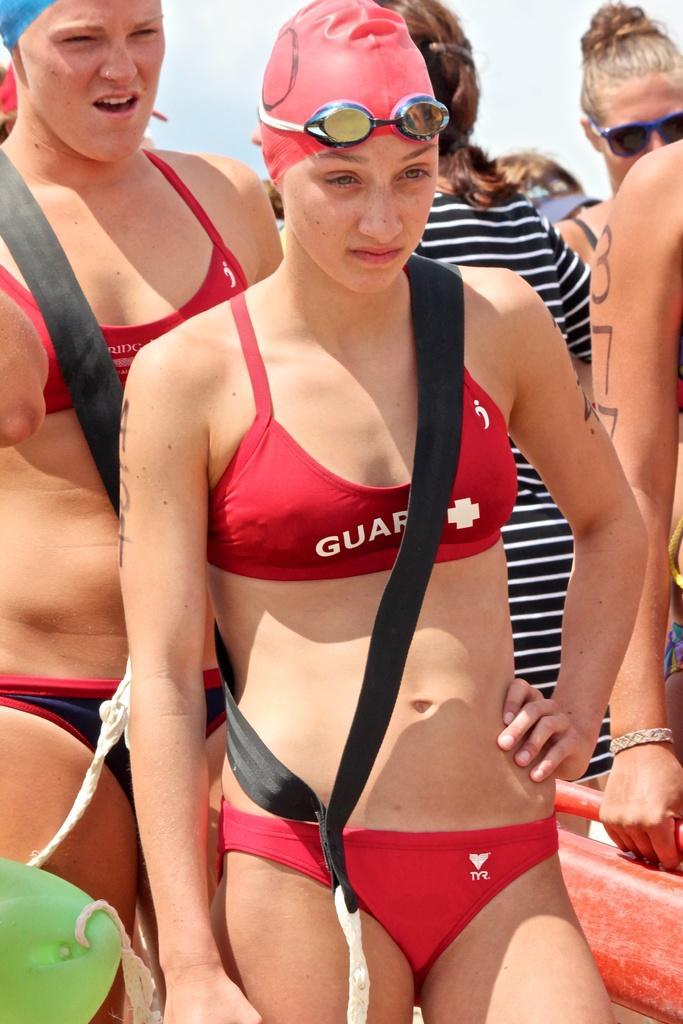Can you describe this image briefly? In this picture there is a woman who is wearing cap, goggles, bag and red dress. Beside her there is another woman who is wearing the bikini. On the right there is a woman who is wearing blue and white color strip t-shirt and she is standing near to the woman who is wearing goggles. At the top there is a sky. In the bottom left corner there is a ski board. 